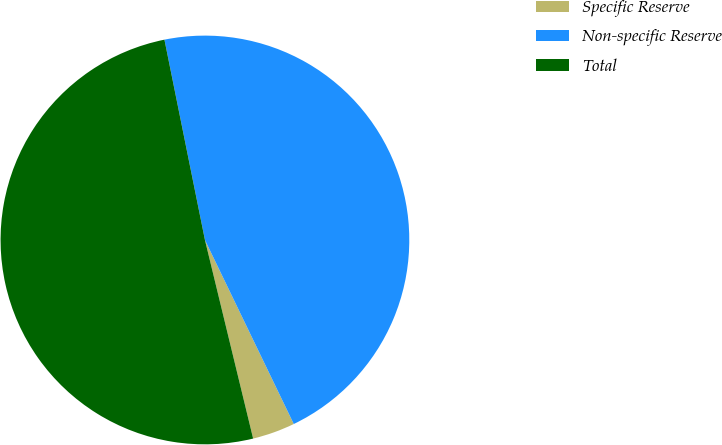<chart> <loc_0><loc_0><loc_500><loc_500><pie_chart><fcel>Specific Reserve<fcel>Non-specific Reserve<fcel>Total<nl><fcel>3.37%<fcel>46.02%<fcel>50.62%<nl></chart> 